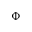Convert formula to latex. <formula><loc_0><loc_0><loc_500><loc_500>\Phi</formula> 